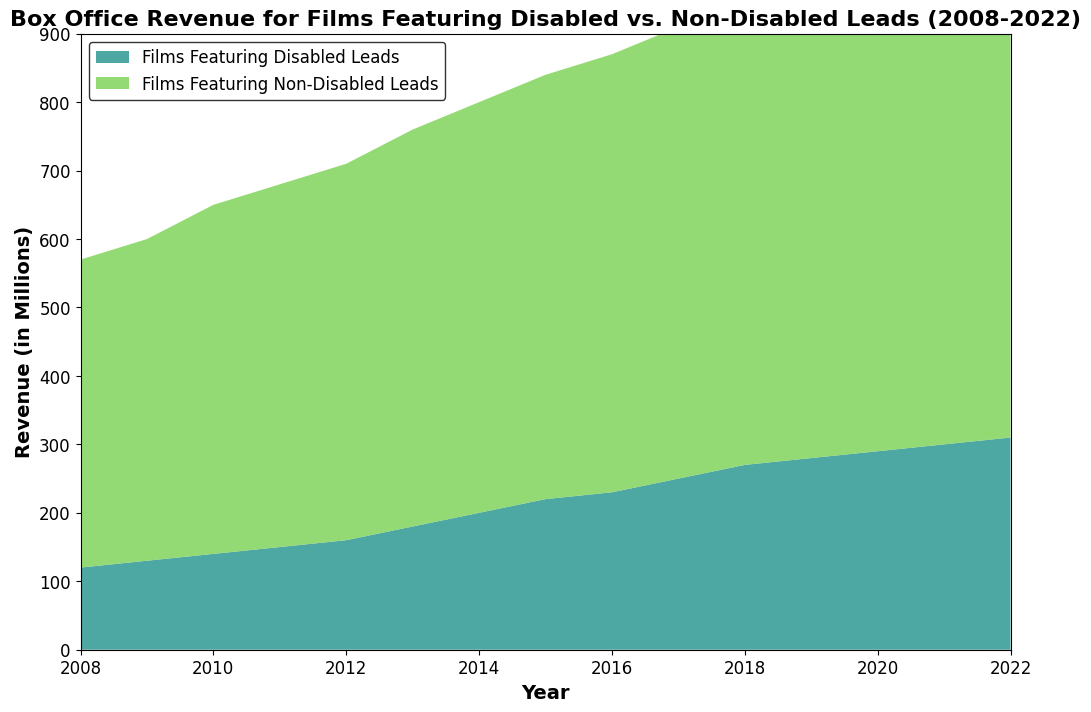What trend can be observed in the box office revenue for films featuring disabled leads over the 15 years? The graph shows a consistent upward trend in the box office revenue for films featuring disabled leads from 2008 to 2022. The revenue starts at $120 million in 2008 and increases to $310 million in 2022.
Answer: Consistent upward trend Which year shows the greatest increase in box office revenue for films featuring non-disabled leads compared to the previous year? The greatest increase appears between 2017 and 2018. In 2017, the revenue was $660 million, and in 2018, it was $700 million, showing an increase of $40 million.
Answer: 2018 What is the combined box office revenue for films featuring both disabled and non-disabled leads in 2022? In 2022, the box office revenue for films featuring disabled leads was $310 million and for non-disabled leads was $780 million. Adding them gives a total combined revenue of $310 million + $780 million = $1090 million.
Answer: $1090 million How did the difference in revenue between films featuring disabled and non-disabled leads evolve between 2008 and 2022? In 2008, the difference was $450 million - $120 million = $330 million. In 2022, the difference was $780 million - $310 million = $470 million. The difference in revenue between the two categories increased by $140 million over the 15 years.
Answer: The difference increased During which period did films featuring disabled leads see the most rapid increase in box office revenue? The most rapid increase in the box office revenue for films featuring disabled leads occurred between 2012 and 2014. From 2012 ($160 million) to 2014 ($200 million), there was an increase of $40 million over just two years.
Answer: 2012 to 2014 At what point do films featuring non-disabled leads start consistently earning more than $600 million annually? Films featuring non-disabled leads start consistently earning more than $600 million annually from 2014 onwards.
Answer: 2014 What is the revenue difference between films featuring disabled and non-disabled leads in the year 2015? In 2015, the revenue for films featuring disabled leads was $220 million, and for non-disabled leads, it was $620 million. The difference is $620 million - $220 million = $400 million.
Answer: $400 million Which category, films featuring disabled leads or non-disabled leads, shows a sharper rate of increase in revenue from 2008 to 2022? Both categories show an increase, but films featuring non-disabled leads consistently have higher growth in absolute numbers. From 2008 to 2022, films featuring non-disabled leads increase from $450 million to $780 million (+ $330 million), while those featuring disabled leads go from $120 million to $310 million (+ $190 million). Therefore, non-disabled leads show a sharper rate of increase.
Answer: Non-disabled leads What visual differences can be observed in the stacked area chart for the two categories of films? The area representing films featuring non-disabled leads is larger and more dominant, with a pronounced upward trend. The area for disabled leads is smaller but also shows a steady increase over time. The colors used to distinguish the categories are different, making them visually distinct.
Answer: Larger area for non-disabled, steady increase in both From the area chart, in which years do films featuring disabled leads surpass $200 million in revenue? Films featuring disabled leads surpass $200 million in revenue starting from 2014 onwards.
Answer: 2014 